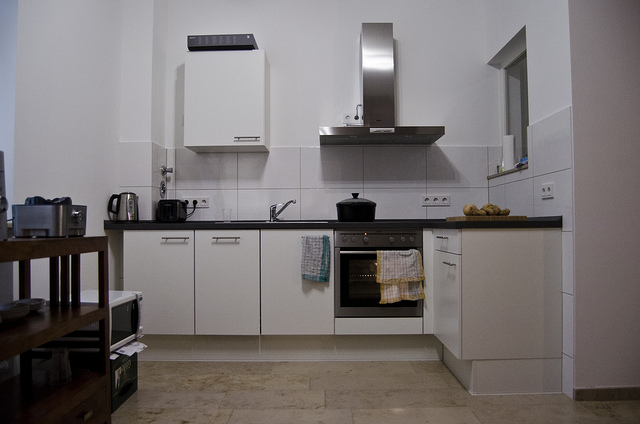<image>What is on the top of the knives cabinet? It is unknown what is on the top of the knives cabinet. What is on the top of the knives cabinet? I am not sure what is on the top of the knives cabinet. It can be seen 'vcr', 'container', 'cutting board', 'no knives', 'nothing', 'wall', 'unknown', 'box', 'knives' or 'countertop'. 